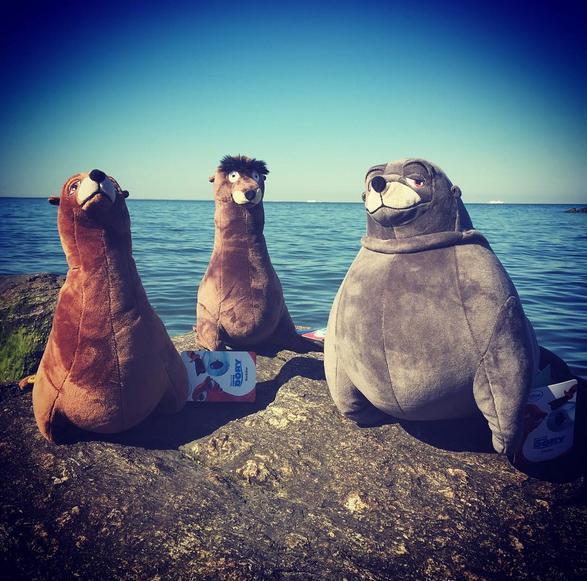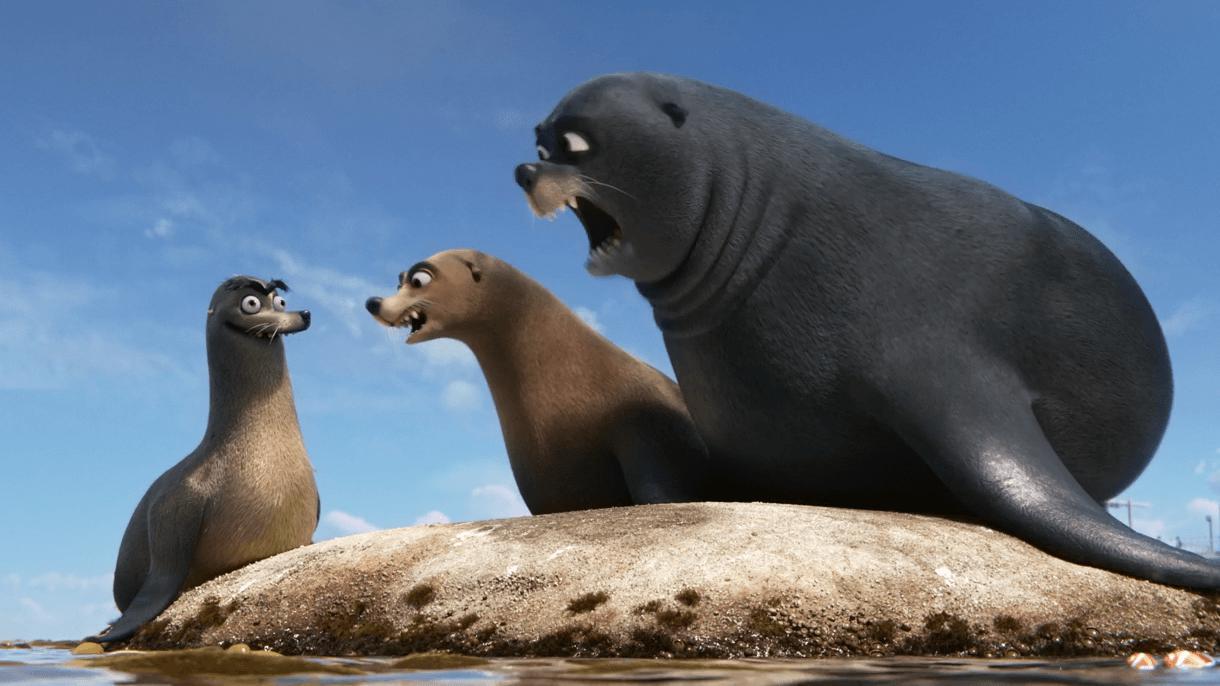The first image is the image on the left, the second image is the image on the right. Evaluate the accuracy of this statement regarding the images: "Four animals are sitting on rocks near the water.". Is it true? Answer yes or no. No. The first image is the image on the left, the second image is the image on the right. For the images shown, is this caption "An image includes a large seal with wide-open mouth and a smaller seal with a closed mouth." true? Answer yes or no. Yes. 